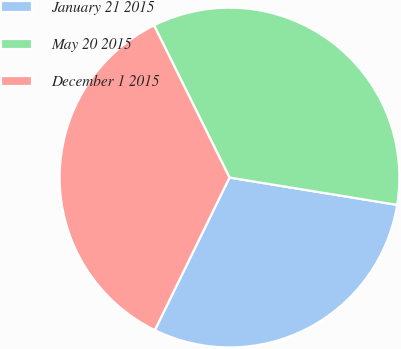Convert chart. <chart><loc_0><loc_0><loc_500><loc_500><pie_chart><fcel>January 21 2015<fcel>May 20 2015<fcel>December 1 2015<nl><fcel>29.67%<fcel>34.9%<fcel>35.43%<nl></chart> 